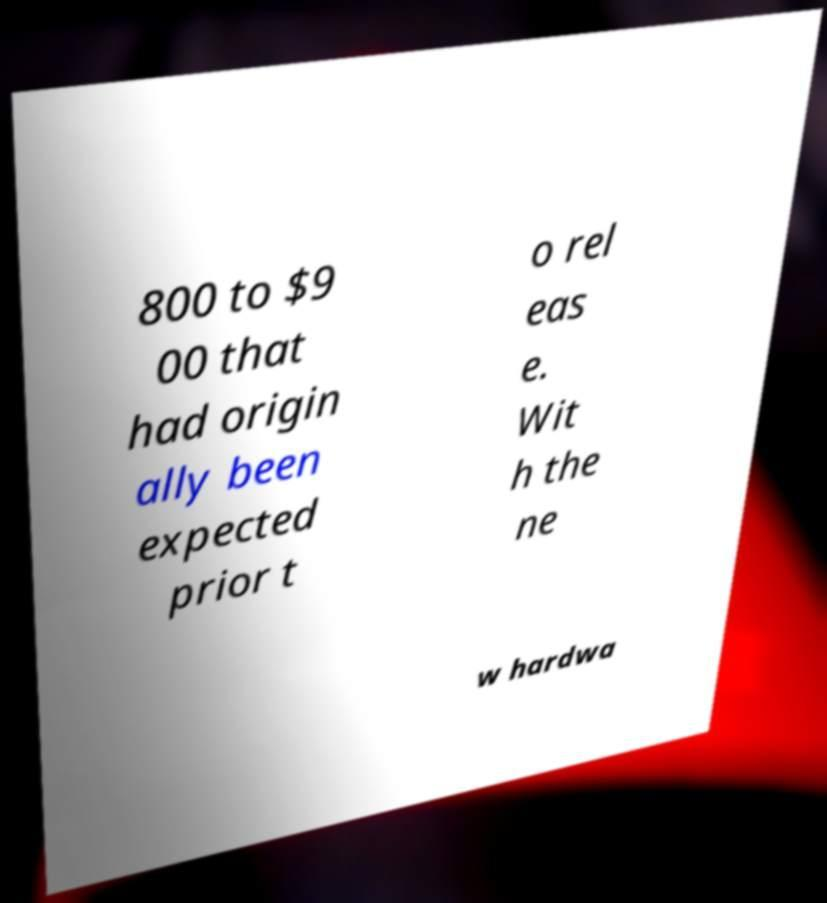Could you extract and type out the text from this image? 800 to $9 00 that had origin ally been expected prior t o rel eas e. Wit h the ne w hardwa 